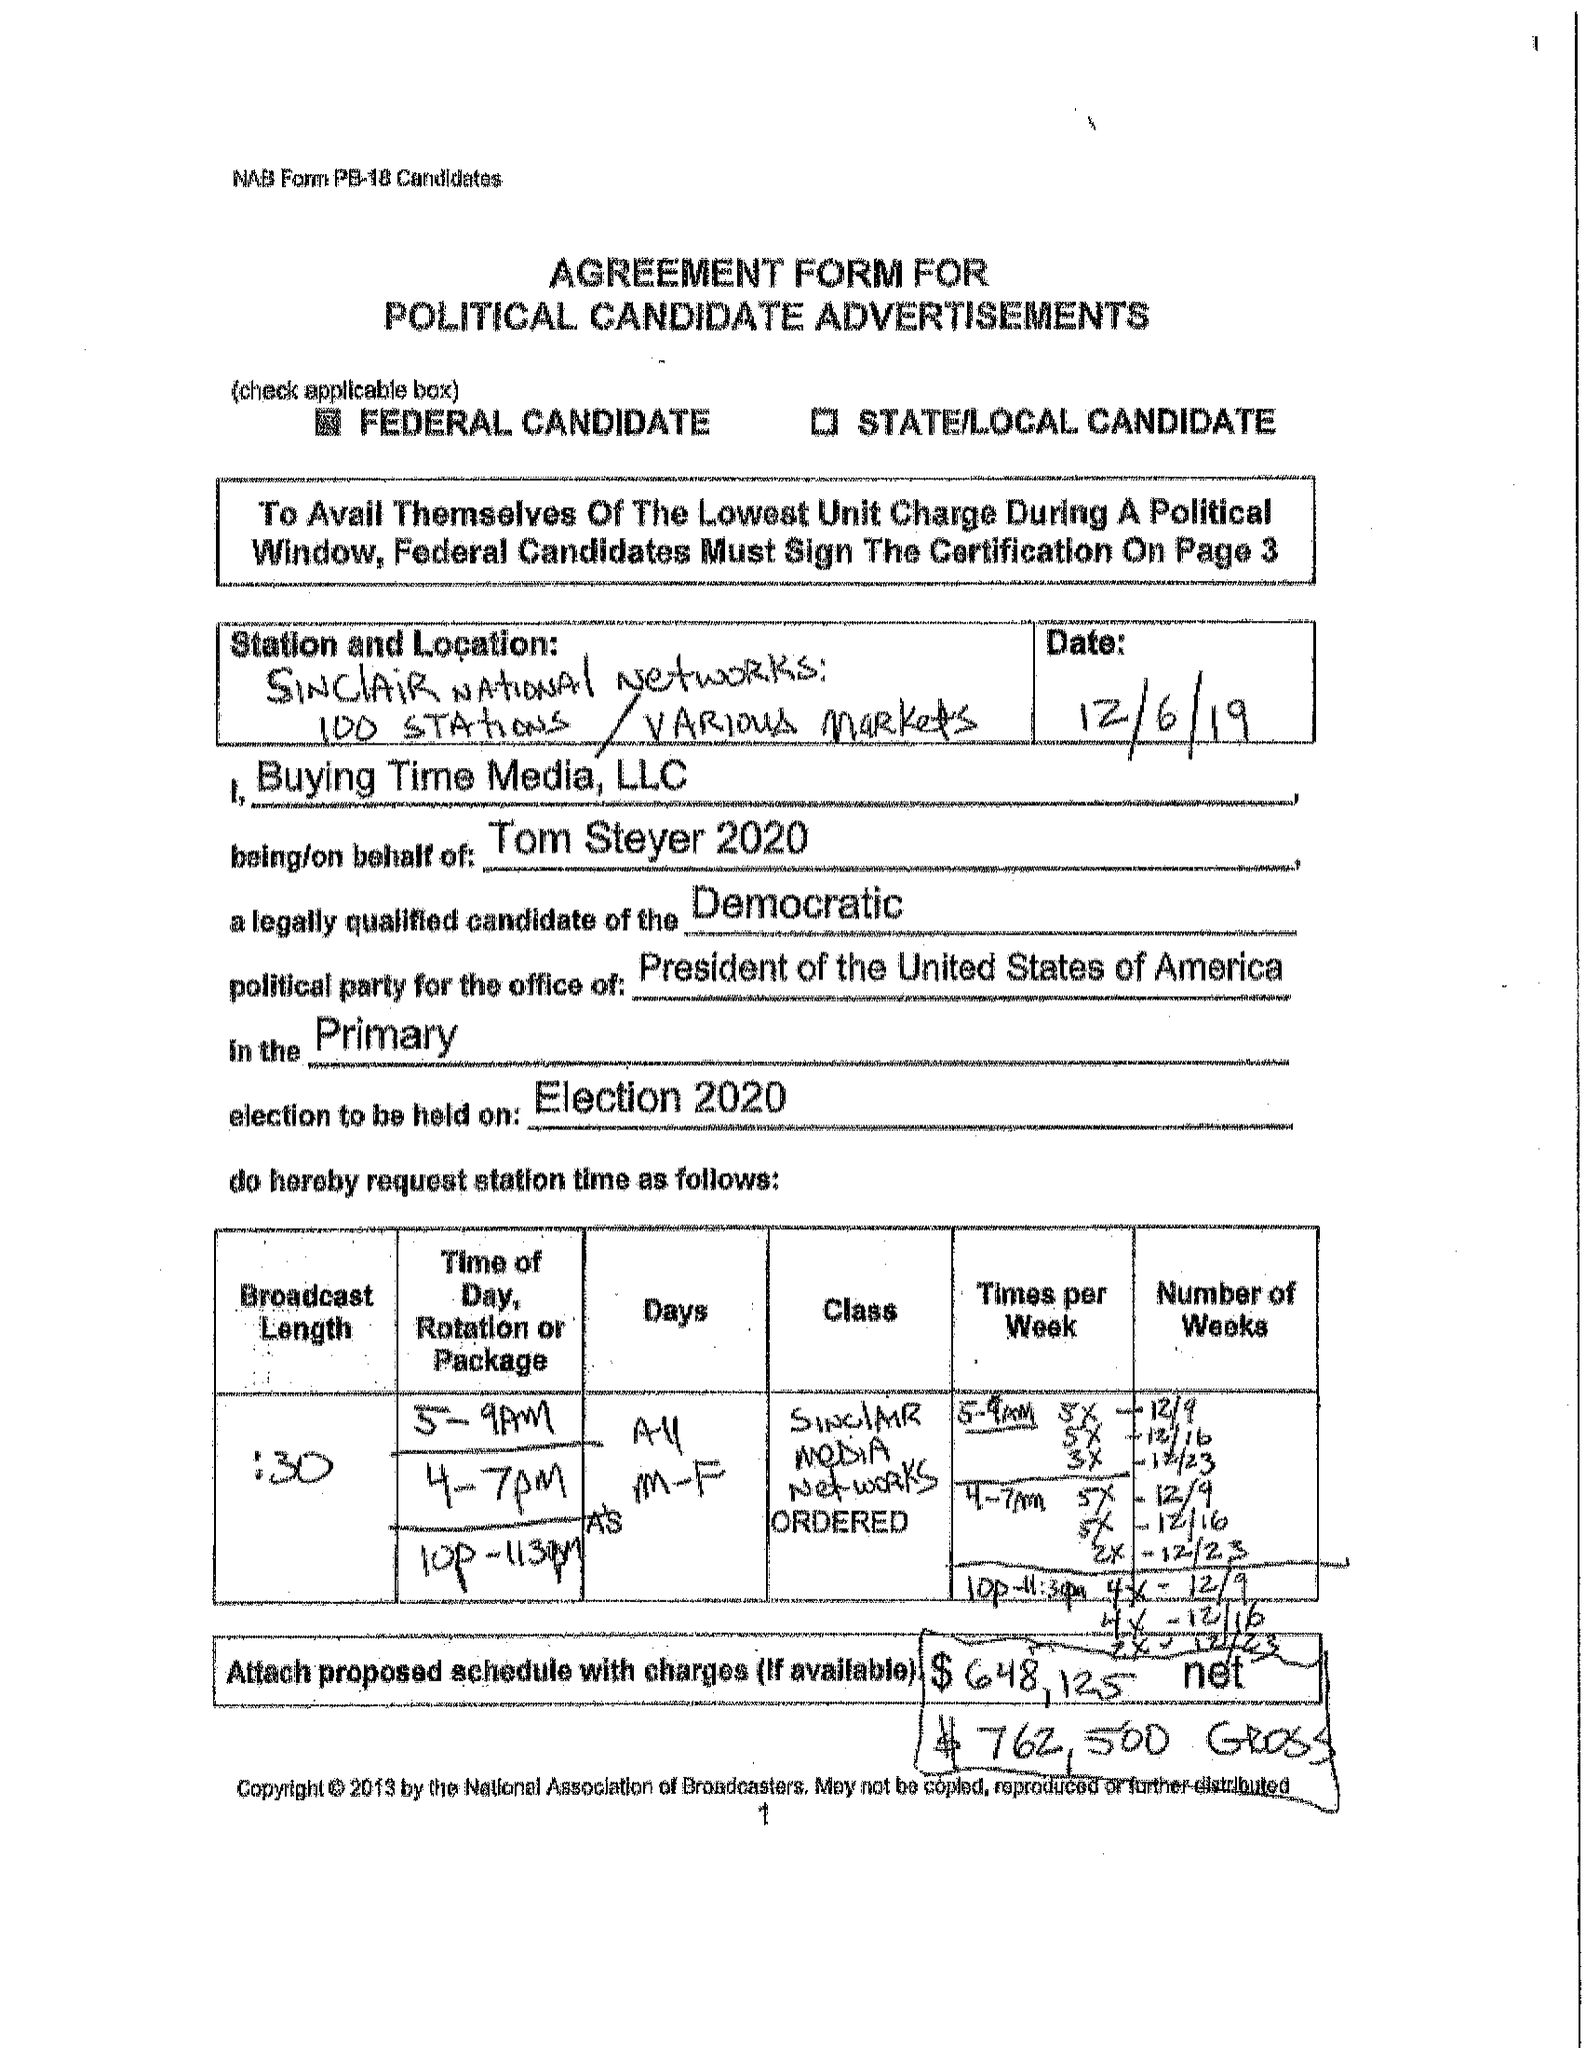What is the value for the flight_to?
Answer the question using a single word or phrase. 12/29/19 